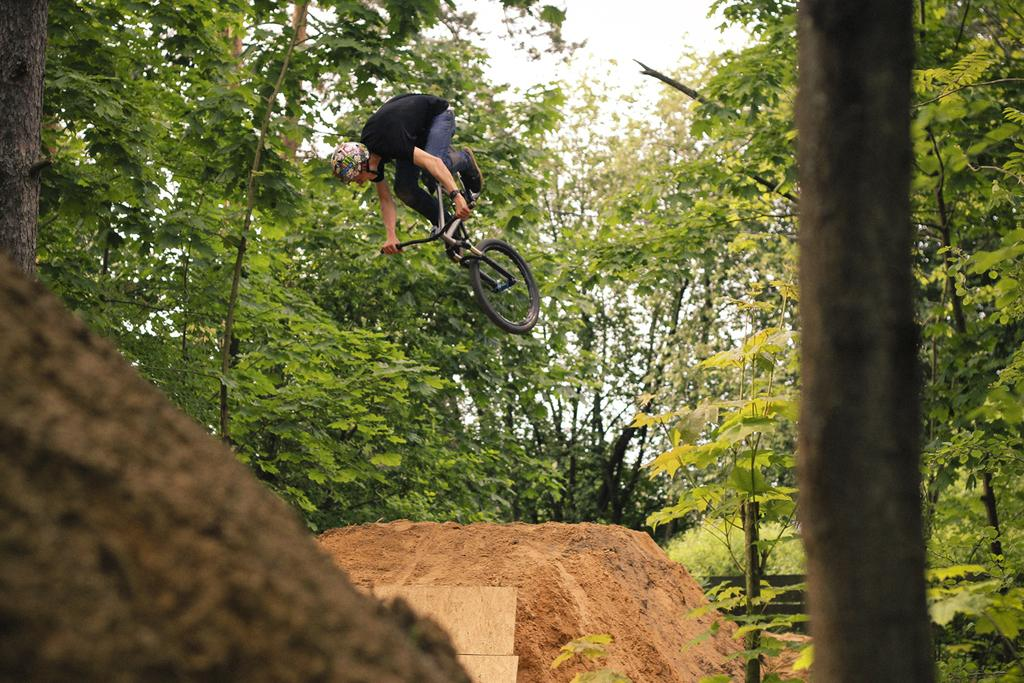What is happening in the image? There is a person in the image who is flying with a bicycle. What can be seen on the ground in the image? There is mud on the ground in the image. What is visible in the background of the image? Trees and the sky are visible in the background of the image. What type of beef is being served at the picnic in the image? There is no picnic or beef present in the image; it features a person flying with a bicycle. What rule is being enforced by the person on the bicycle in the image? There is no rule enforcement or indication of a rule in the image; it simply shows a person flying with a bicycle. 